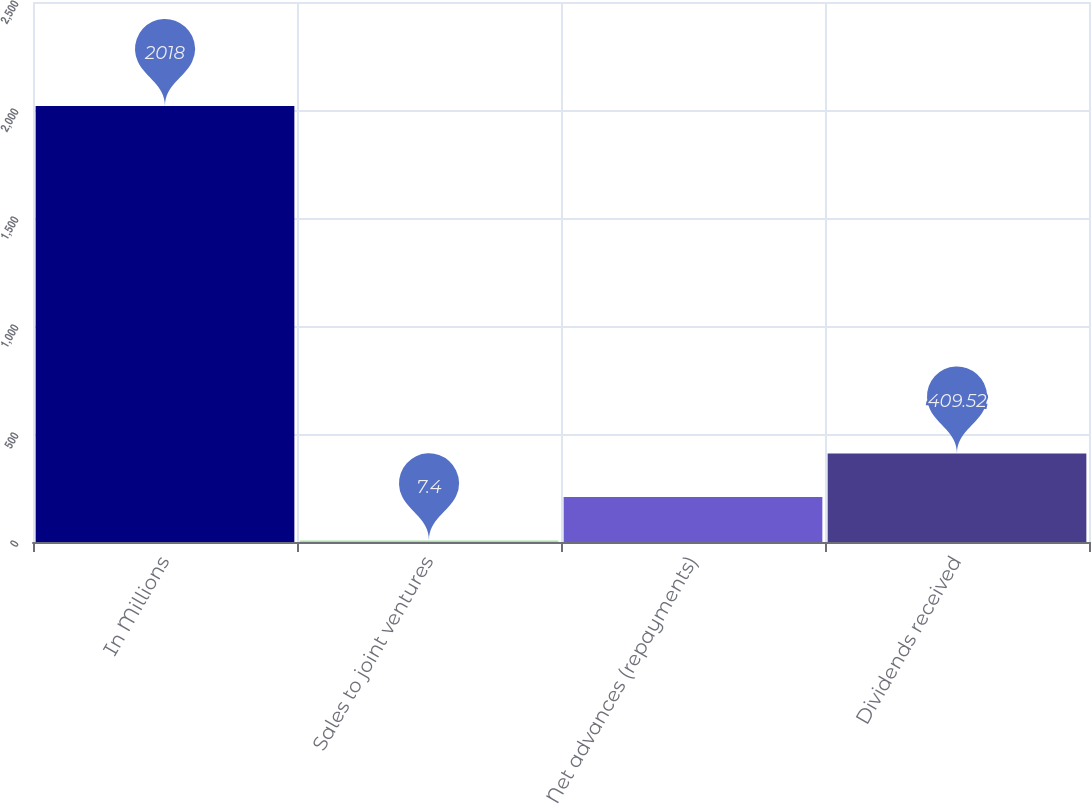Convert chart. <chart><loc_0><loc_0><loc_500><loc_500><bar_chart><fcel>In Millions<fcel>Sales to joint ventures<fcel>Net advances (repayments)<fcel>Dividends received<nl><fcel>2018<fcel>7.4<fcel>208.46<fcel>409.52<nl></chart> 